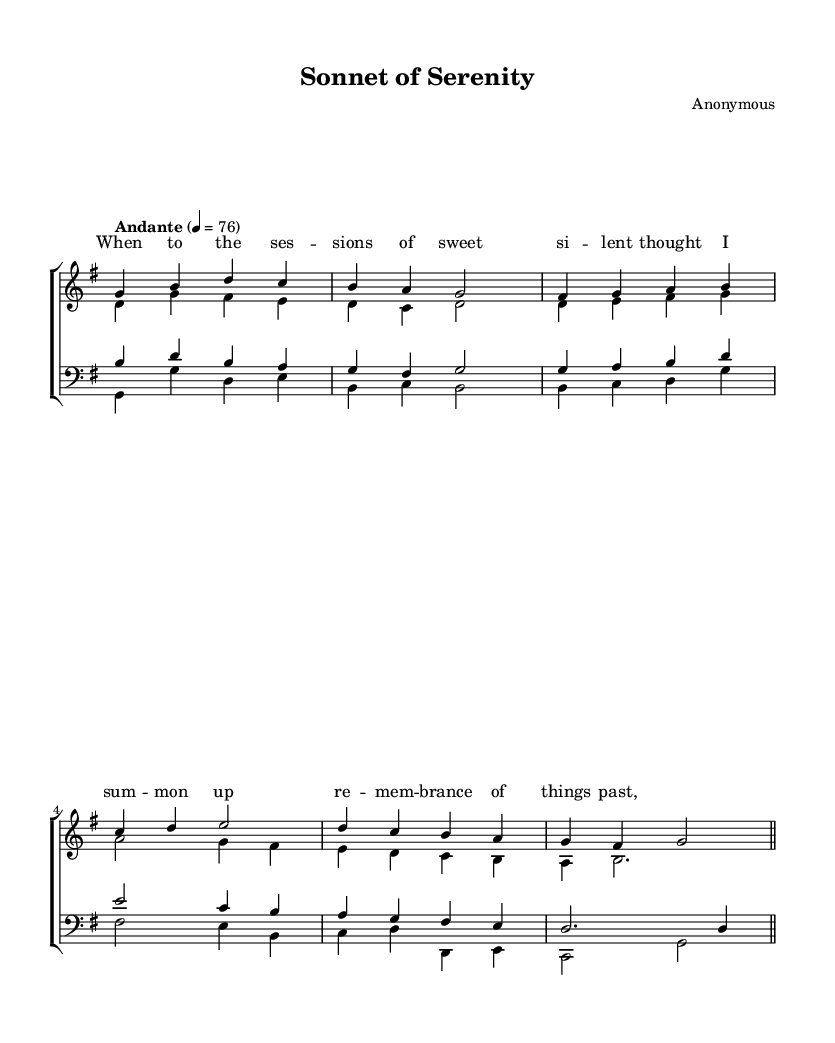What is the key signature of this music? The key signature indicates G major, which has one sharp (F#). This is shown at the beginning of the staff notation.
Answer: G major What is the time signature of this music? The time signature is 4/4, meaning there are four beats in each measure. It is displayed at the beginning of the score next to the key signature.
Answer: 4/4 What is the tempo marking indicated? The tempo marking is "Andante", which suggests a moderate pace for the performance. This is found below the global settings.
Answer: Andante How many measures are in the soprano part? The soprano part consists of six measures, which can be counted by looking at the distinct separation of notes and the barlines in the staff.
Answer: Six Which voice sings the lowest part? The bass voice sings the lowest part, indicated by the lowest staff with the bass clef symbol, which designates lower pitches.
Answer: Bass What is the final note of the tenor part? The final note of the tenor part is D, which is indicated at the end of the last measure for that voice.
Answer: D How many verses are provided in the lyrics? There is one verse provided in the lyrics, shown as a single set of text aligned with the soprano part above.
Answer: One 